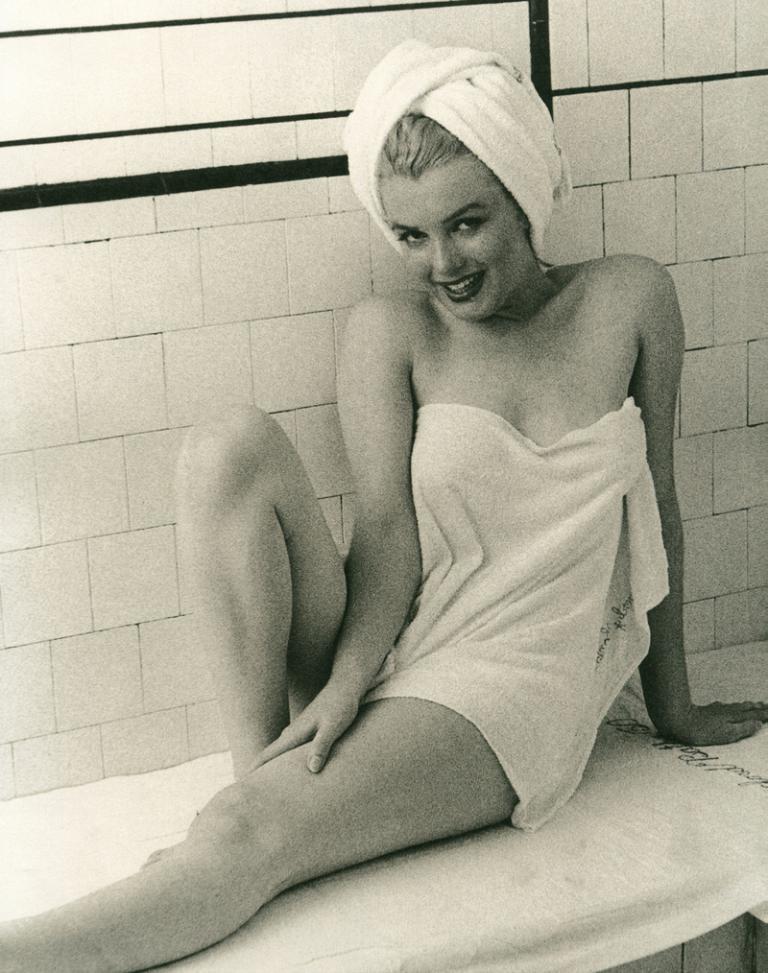Could you give a brief overview of what you see in this image? In this image, in the middle, we can see a woman sitting on the bed. In the background, we can see a wall. 